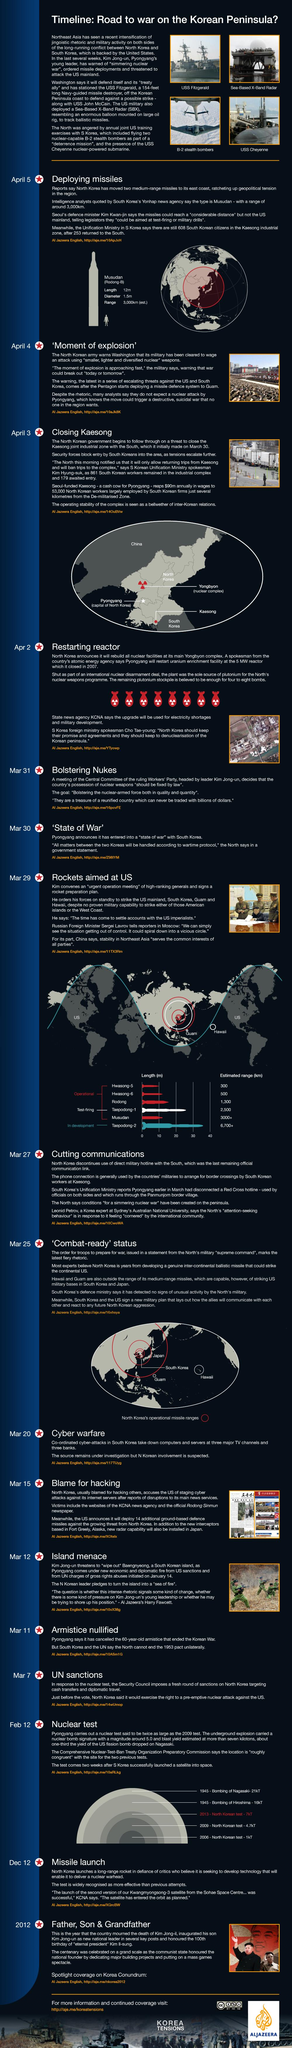Specify some key components in this picture. On August 9, 1945, the United States dropped the atom bomb on Nagasaki, marking a turning point in the history of humanity and bringing an end to World War II. It is known that the capital of North Korea is Pyongyang. The atomic bomb dropped on Hiroshima had a blast yield of 16 kilotons of TNT. Kim Jong-il was the leader of North Korea prior to Kim Jong-un. 